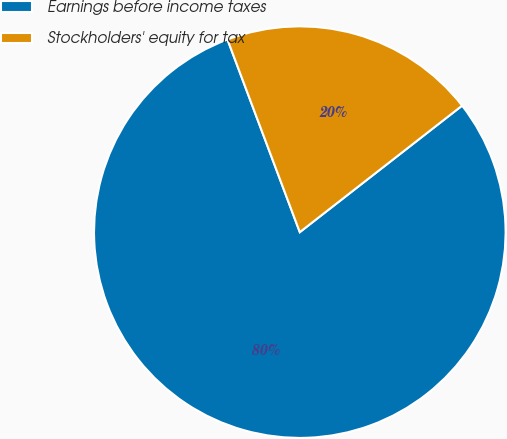Convert chart to OTSL. <chart><loc_0><loc_0><loc_500><loc_500><pie_chart><fcel>Earnings before income taxes<fcel>Stockholders' equity for tax<nl><fcel>79.82%<fcel>20.18%<nl></chart> 